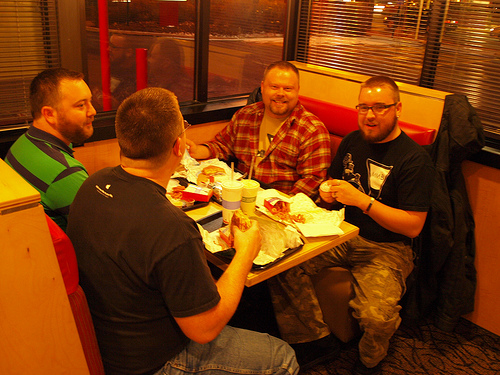<image>
Is the man in front of the window? No. The man is not in front of the window. The spatial positioning shows a different relationship between these objects. 